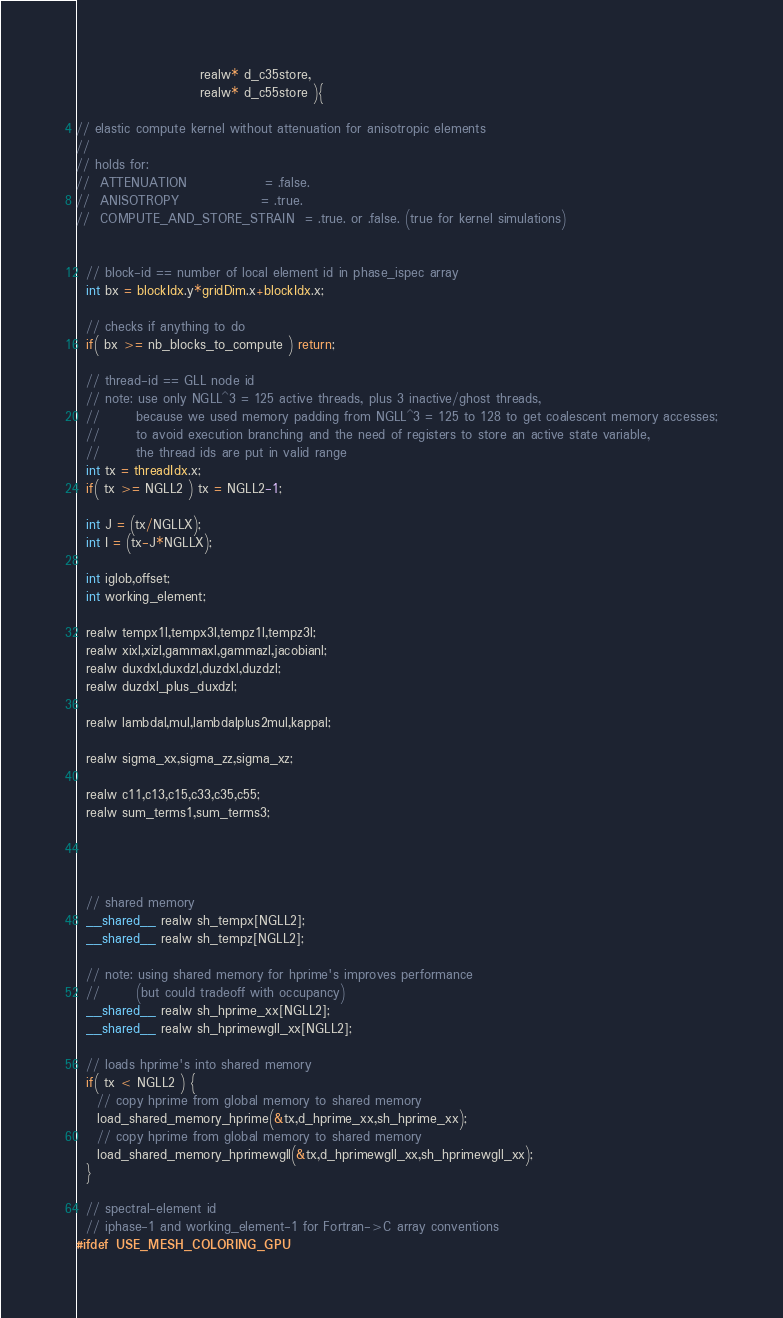Convert code to text. <code><loc_0><loc_0><loc_500><loc_500><_Cuda_>                        realw* d_c35store,
                        realw* d_c55store ){

// elastic compute kernel without attenuation for anisotropic elements
//
// holds for:
//  ATTENUATION               = .false.
//  ANISOTROPY                = .true.
//  COMPUTE_AND_STORE_STRAIN  = .true. or .false. (true for kernel simulations)


  // block-id == number of local element id in phase_ispec array
  int bx = blockIdx.y*gridDim.x+blockIdx.x;

  // checks if anything to do
  if( bx >= nb_blocks_to_compute ) return;

  // thread-id == GLL node id
  // note: use only NGLL^3 = 125 active threads, plus 3 inactive/ghost threads,
  //       because we used memory padding from NGLL^3 = 125 to 128 to get coalescent memory accesses;
  //       to avoid execution branching and the need of registers to store an active state variable,
  //       the thread ids are put in valid range
  int tx = threadIdx.x;
  if( tx >= NGLL2 ) tx = NGLL2-1;

  int J = (tx/NGLLX);
  int I = (tx-J*NGLLX);

  int iglob,offset;
  int working_element;

  realw tempx1l,tempx3l,tempz1l,tempz3l;
  realw xixl,xizl,gammaxl,gammazl,jacobianl;
  realw duxdxl,duxdzl,duzdxl,duzdzl;
  realw duzdxl_plus_duxdzl;

  realw lambdal,mul,lambdalplus2mul,kappal;

  realw sigma_xx,sigma_zz,sigma_xz;

  realw c11,c13,c15,c33,c35,c55;
  realw sum_terms1,sum_terms3;




  // shared memory
  __shared__ realw sh_tempx[NGLL2];
  __shared__ realw sh_tempz[NGLL2];

  // note: using shared memory for hprime's improves performance
  //       (but could tradeoff with occupancy)
  __shared__ realw sh_hprime_xx[NGLL2];
  __shared__ realw sh_hprimewgll_xx[NGLL2];

  // loads hprime's into shared memory
  if( tx < NGLL2 ) {
    // copy hprime from global memory to shared memory
    load_shared_memory_hprime(&tx,d_hprime_xx,sh_hprime_xx);
    // copy hprime from global memory to shared memory
    load_shared_memory_hprimewgll(&tx,d_hprimewgll_xx,sh_hprimewgll_xx);
  }

  // spectral-element id
  // iphase-1 and working_element-1 for Fortran->C array conventions
#ifdef USE_MESH_COLORING_GPU</code> 